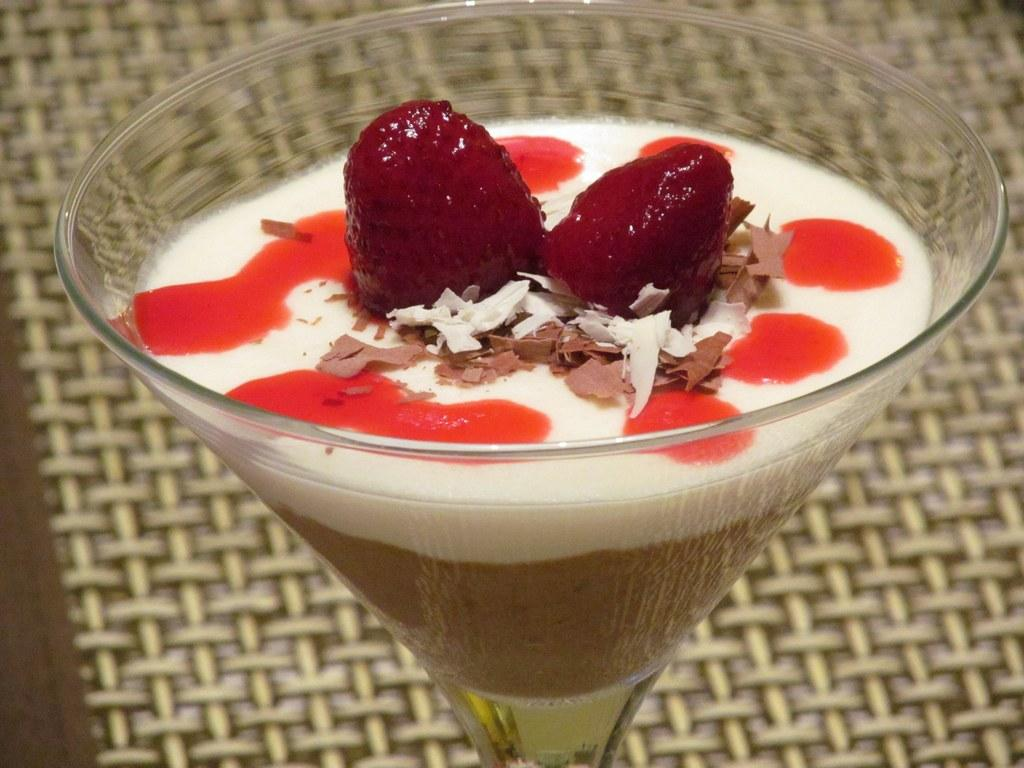What is inside the glass that is visible in the image? There is a food item in the glass in the image. What can be seen in the background of the image? There is a table mat in the background of the image. What type of guide can be seen walking down the street in the image? There is no guide or street present in the image; it only features a glass with a food item and a table mat in the background. 